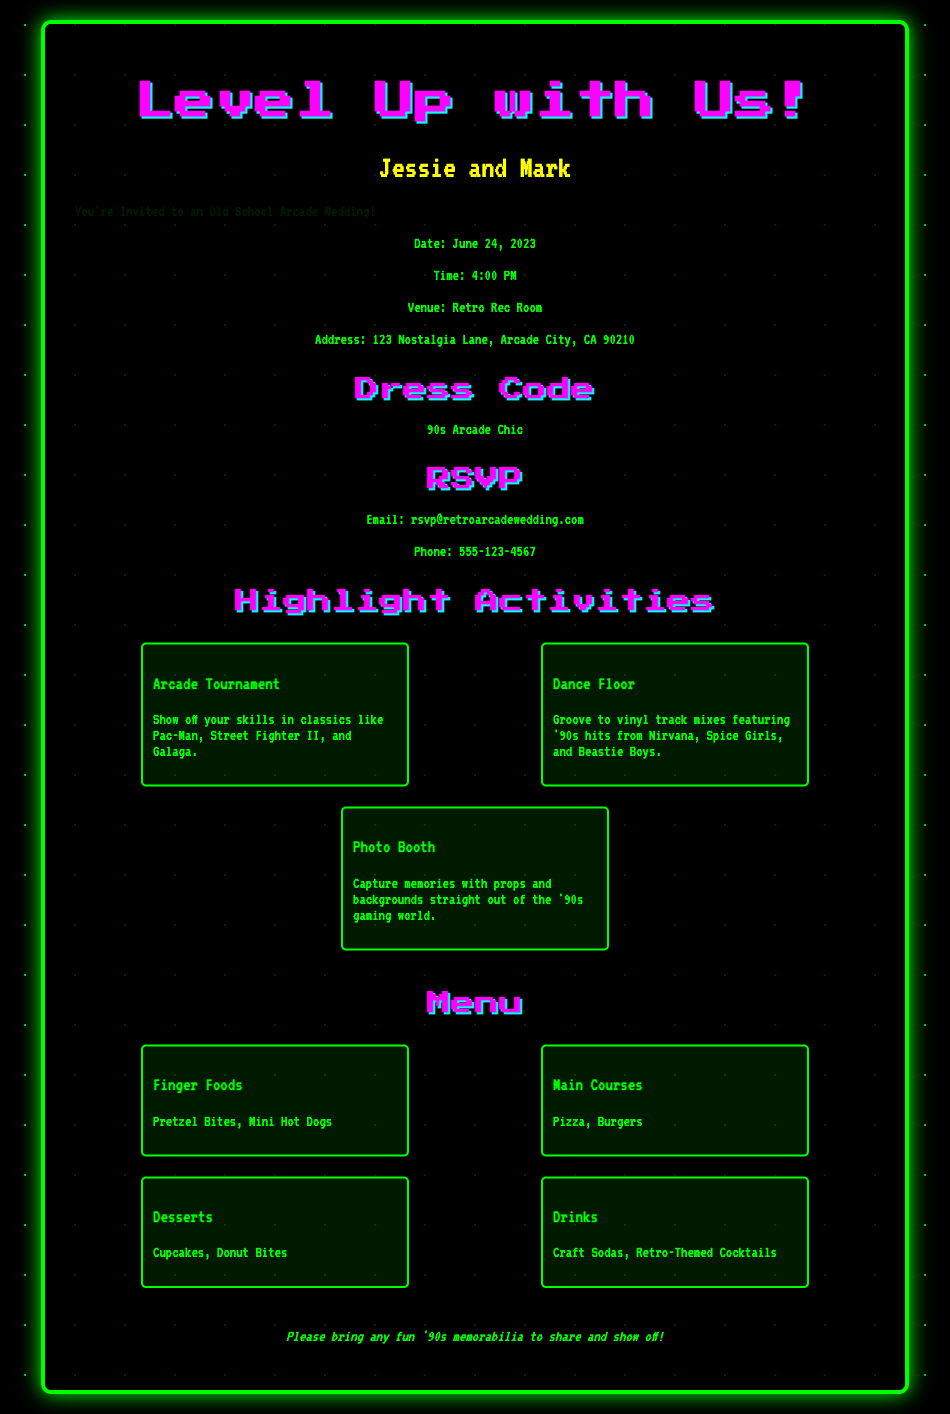What is the name of the couple getting married? The name of the couple is presented prominently on the invitation.
Answer: Jessie and Mark What is the date of the wedding? The date is specified in the event details section of the invitation.
Answer: June 24, 2023 What time does the wedding start? The starting time of the event is also included in the event details.
Answer: 4:00 PM Where is the wedding venue located? The venue address is stated under event details.
Answer: Retro Rec Room, 123 Nostalgia Lane, Arcade City, CA 90210 What is the dress code for the wedding? The dress code is highlighted in a dedicated section of the invitation.
Answer: 90s Arcade Chic What type of activities are planned for the wedding? The activities section lists things to expect during the event, indicating various games and entertainment.
Answer: Arcade Tournament, Dance Floor, Photo Booth What is one of the dessert options on the menu? The menu section details what food will be served, including dessert choices.
Answer: Cupcakes Where should guests send their RSVP? The RSVP section specifies the contact details for responses.
Answer: rsvp@retroarcadewedding.com What special instructions are provided for guests? The special instructions request something specific from guests, adding a nostalgic touch.
Answer: Please bring any fun '90s memorabilia to share and show off! 